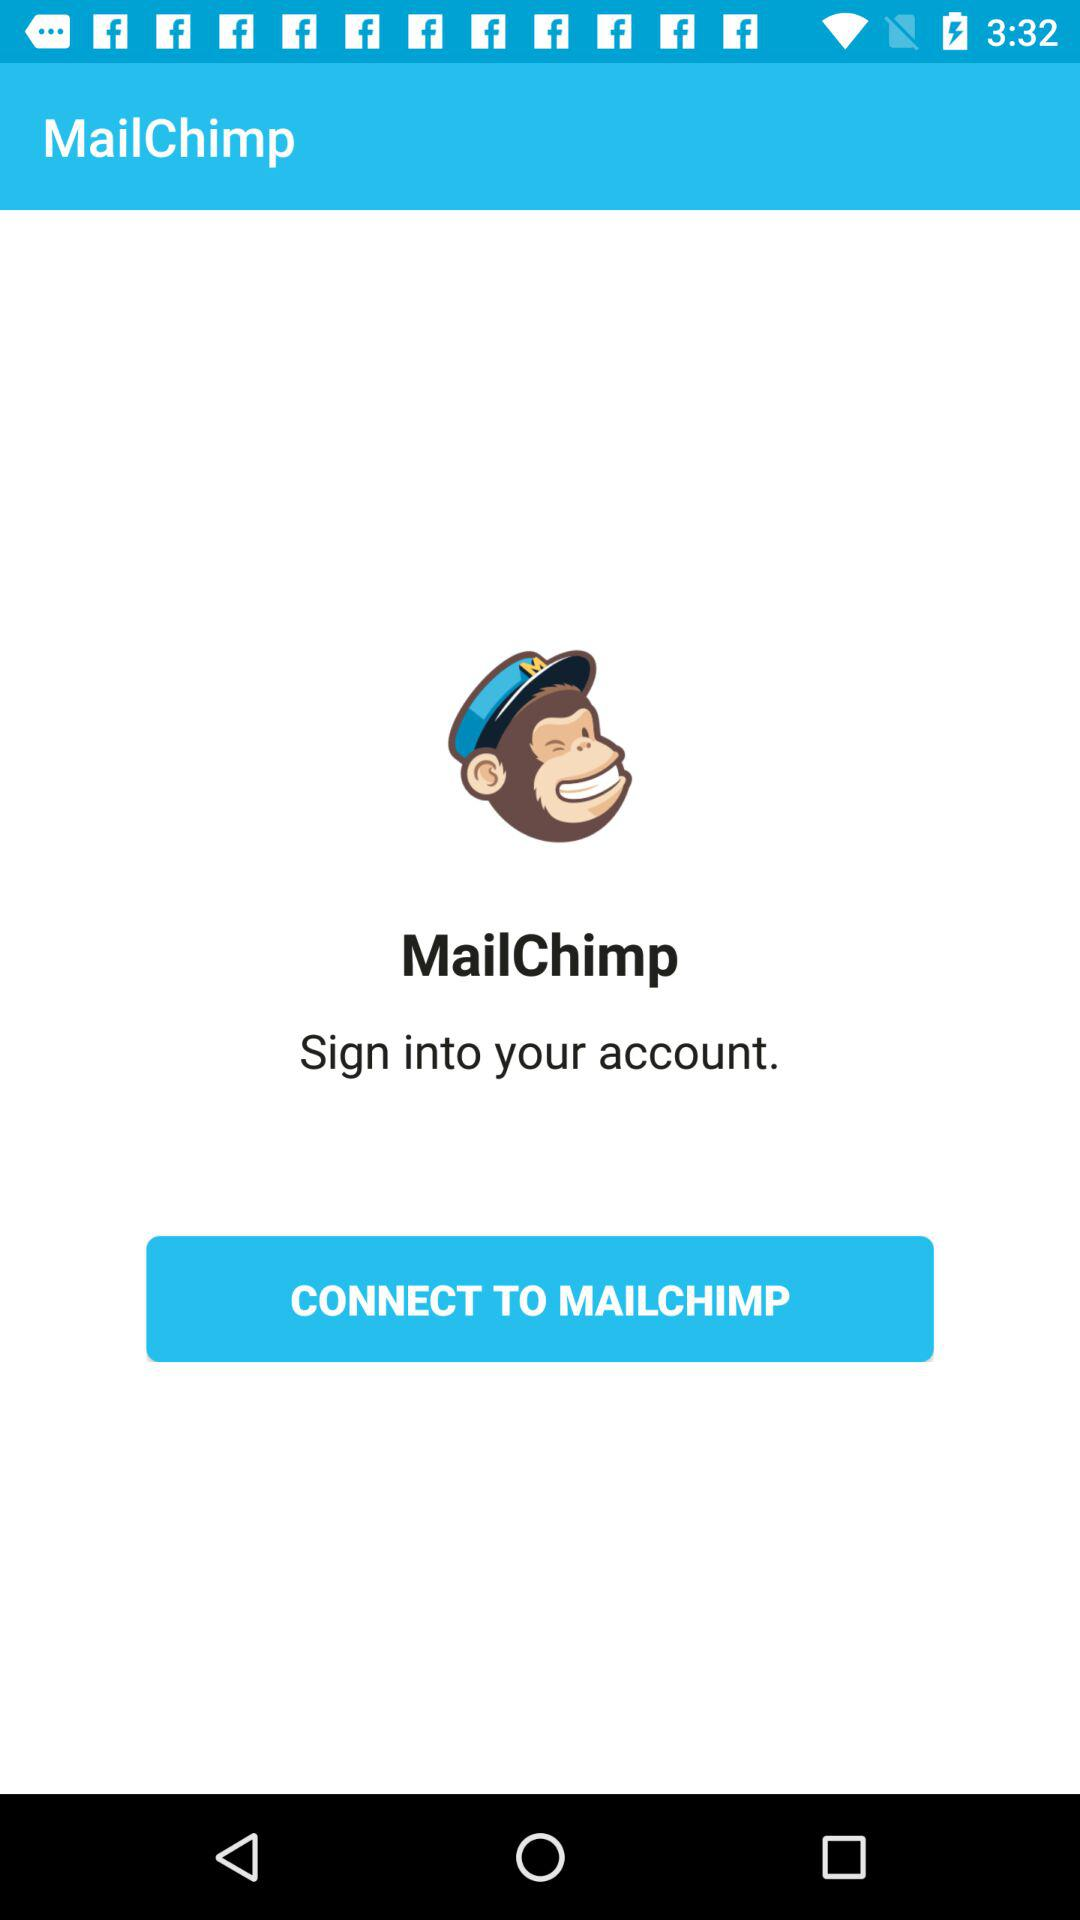What is the user name?
When the provided information is insufficient, respond with <no answer>. <no answer> 